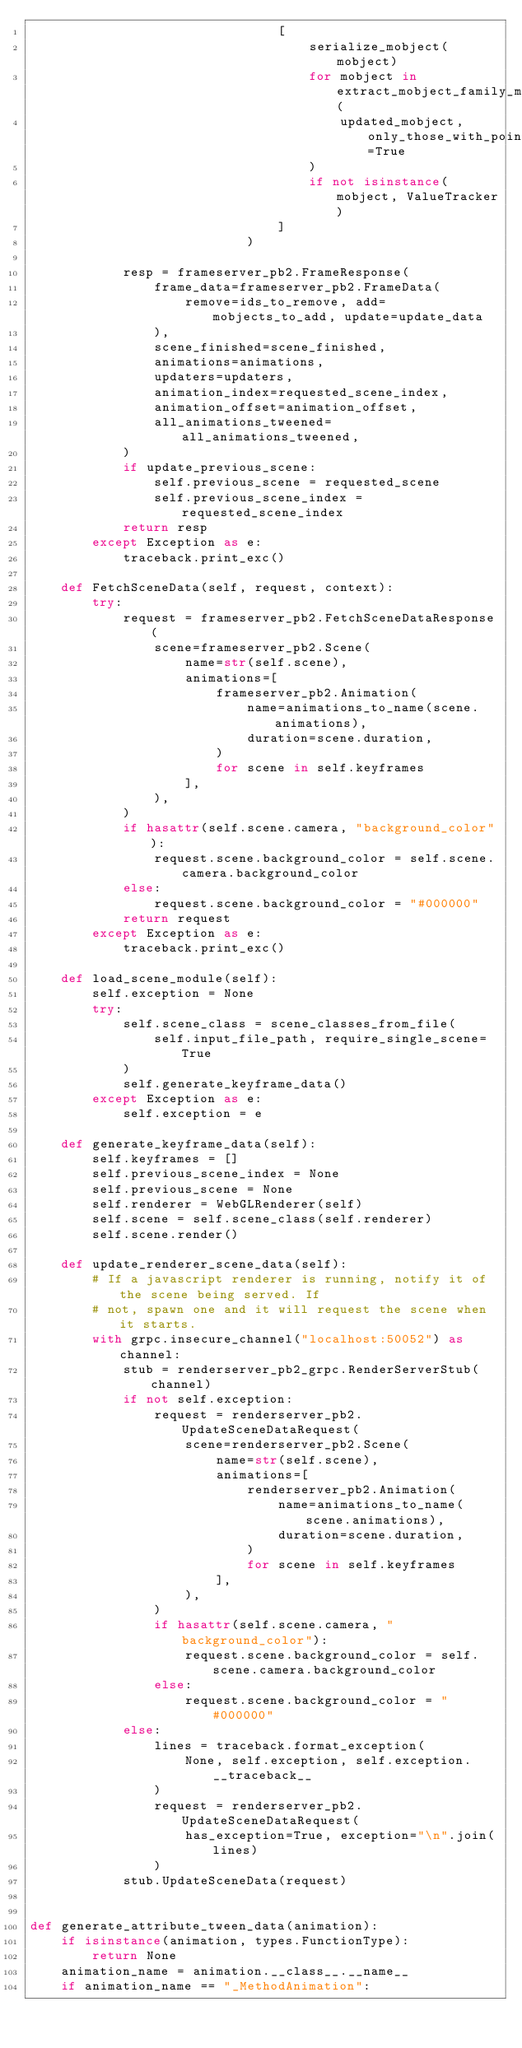Convert code to text. <code><loc_0><loc_0><loc_500><loc_500><_Python_>                                [
                                    serialize_mobject(mobject)
                                    for mobject in extract_mobject_family_members(
                                        updated_mobject, only_those_with_points=True
                                    )
                                    if not isinstance(mobject, ValueTracker)
                                ]
                            )

            resp = frameserver_pb2.FrameResponse(
                frame_data=frameserver_pb2.FrameData(
                    remove=ids_to_remove, add=mobjects_to_add, update=update_data
                ),
                scene_finished=scene_finished,
                animations=animations,
                updaters=updaters,
                animation_index=requested_scene_index,
                animation_offset=animation_offset,
                all_animations_tweened=all_animations_tweened,
            )
            if update_previous_scene:
                self.previous_scene = requested_scene
                self.previous_scene_index = requested_scene_index
            return resp
        except Exception as e:
            traceback.print_exc()

    def FetchSceneData(self, request, context):
        try:
            request = frameserver_pb2.FetchSceneDataResponse(
                scene=frameserver_pb2.Scene(
                    name=str(self.scene),
                    animations=[
                        frameserver_pb2.Animation(
                            name=animations_to_name(scene.animations),
                            duration=scene.duration,
                        )
                        for scene in self.keyframes
                    ],
                ),
            )
            if hasattr(self.scene.camera, "background_color"):
                request.scene.background_color = self.scene.camera.background_color
            else:
                request.scene.background_color = "#000000"
            return request
        except Exception as e:
            traceback.print_exc()

    def load_scene_module(self):
        self.exception = None
        try:
            self.scene_class = scene_classes_from_file(
                self.input_file_path, require_single_scene=True
            )
            self.generate_keyframe_data()
        except Exception as e:
            self.exception = e

    def generate_keyframe_data(self):
        self.keyframes = []
        self.previous_scene_index = None
        self.previous_scene = None
        self.renderer = WebGLRenderer(self)
        self.scene = self.scene_class(self.renderer)
        self.scene.render()

    def update_renderer_scene_data(self):
        # If a javascript renderer is running, notify it of the scene being served. If
        # not, spawn one and it will request the scene when it starts.
        with grpc.insecure_channel("localhost:50052") as channel:
            stub = renderserver_pb2_grpc.RenderServerStub(channel)
            if not self.exception:
                request = renderserver_pb2.UpdateSceneDataRequest(
                    scene=renderserver_pb2.Scene(
                        name=str(self.scene),
                        animations=[
                            renderserver_pb2.Animation(
                                name=animations_to_name(scene.animations),
                                duration=scene.duration,
                            )
                            for scene in self.keyframes
                        ],
                    ),
                )
                if hasattr(self.scene.camera, "background_color"):
                    request.scene.background_color = self.scene.camera.background_color
                else:
                    request.scene.background_color = "#000000"
            else:
                lines = traceback.format_exception(
                    None, self.exception, self.exception.__traceback__
                )
                request = renderserver_pb2.UpdateSceneDataRequest(
                    has_exception=True, exception="\n".join(lines)
                )
            stub.UpdateSceneData(request)


def generate_attribute_tween_data(animation):
    if isinstance(animation, types.FunctionType):
        return None
    animation_name = animation.__class__.__name__
    if animation_name == "_MethodAnimation":</code> 